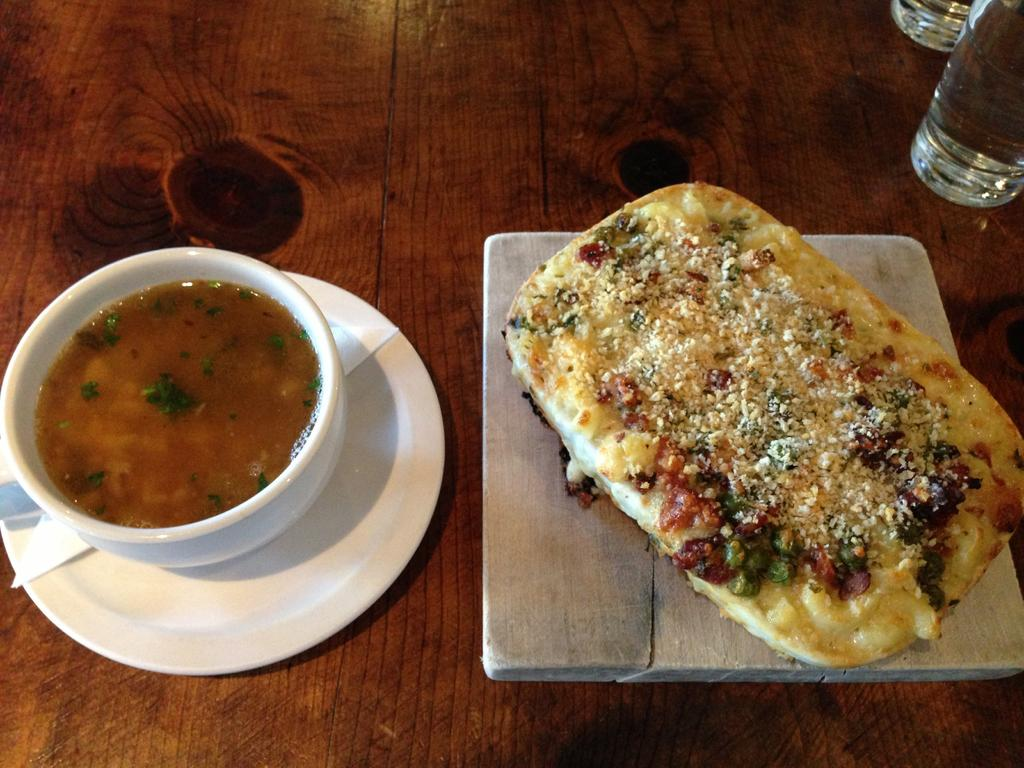What is in the bowl that is visible in the image? There are food items in the bowl that is visible in the image. What is supporting the bowl in the image? There is a plate under the bowl in the image. What is under the plate in the image? There is a paper under the plate in the image. What is the wooden object in the image used for? There is a food item on a wooden object in the image. What type of objects are made of glass on the table in the image? There are glass objects on the table in the image. What type of blade is being used to cut the food on the wooden object in the image? There is no blade visible in the image; it only shows a food item on a wooden object. Can you tell me how many dolls are present in the image? There are no dolls present in the image. 